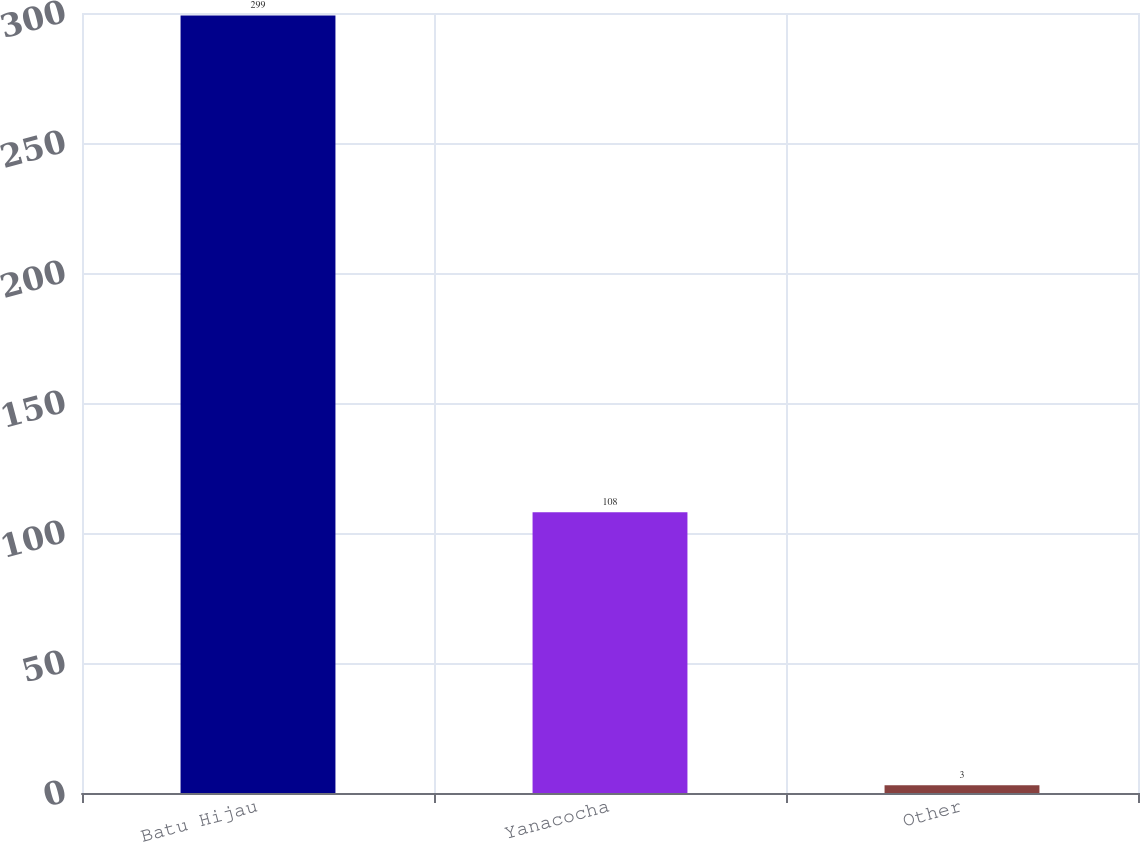Convert chart to OTSL. <chart><loc_0><loc_0><loc_500><loc_500><bar_chart><fcel>Batu Hijau<fcel>Yanacocha<fcel>Other<nl><fcel>299<fcel>108<fcel>3<nl></chart> 